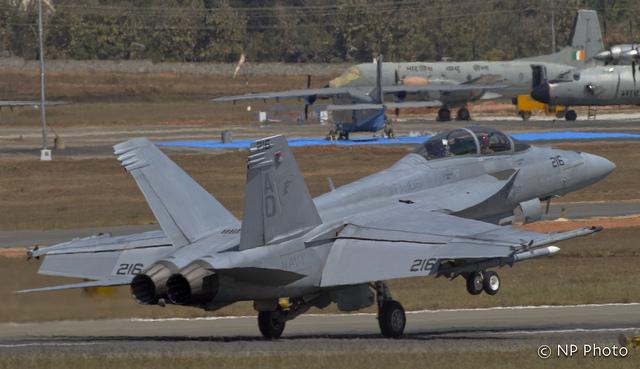Is that a passenger plane?
Write a very short answer. No. Is this a military plane?
Keep it brief. Yes. Is the plane in motion?
Answer briefly. Yes. 